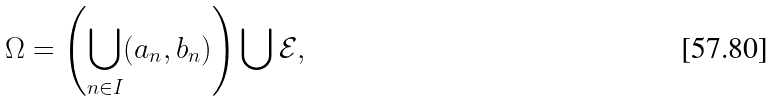Convert formula to latex. <formula><loc_0><loc_0><loc_500><loc_500>\Omega = \left ( \bigcup _ { n \in I } ( a _ { n } , b _ { n } ) \right ) \bigcup \mathcal { E } ,</formula> 